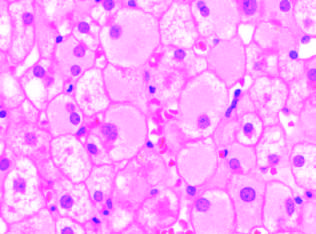what do infected hepatocytes show, reflecting accumulated hepatitis b surface antigen hbsag in chronic infections?
Answer the question using a single word or phrase. Diffuse granular cyto-plasm 